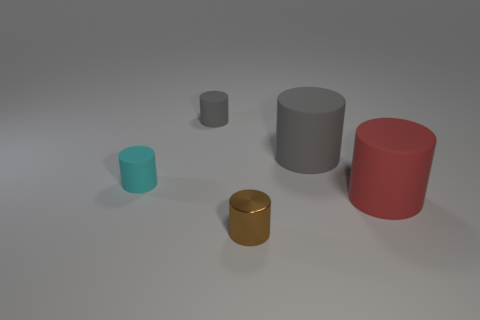Could you imagine a practical use for cylinders like these if they were real objects? If these were real objects, their uses could vary depending on their material and dimensions. For instance, they could serve as containers, pedestals for displaying items, or elements of a modular furniture system. The reflective gold cylinder might be particularly suited as an ornamental piece or a luxury storage container due to its lustrous finish. 